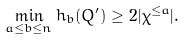Convert formula to latex. <formula><loc_0><loc_0><loc_500><loc_500>\min _ { a \leq b \leq n } h _ { b } ( Q ^ { \prime } ) \geq 2 | \chi ^ { \leq a } | .</formula> 